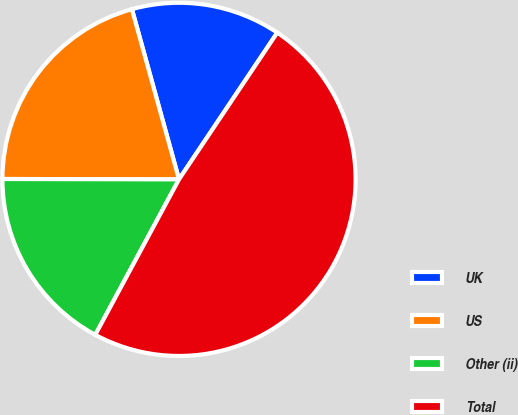<chart> <loc_0><loc_0><loc_500><loc_500><pie_chart><fcel>UK<fcel>US<fcel>Other (ii)<fcel>Total<nl><fcel>13.69%<fcel>20.67%<fcel>17.17%<fcel>48.47%<nl></chart> 